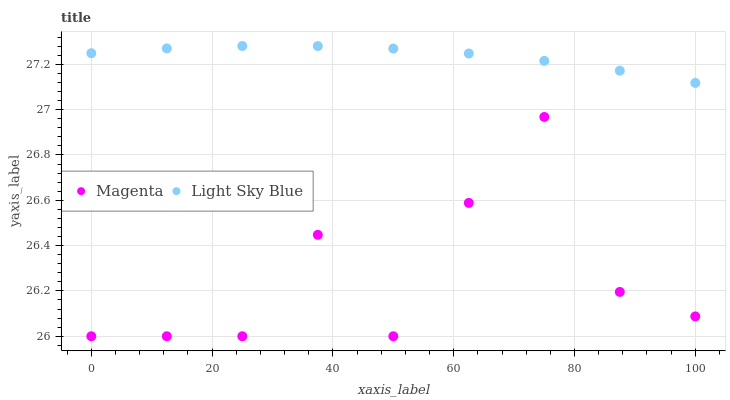Does Magenta have the minimum area under the curve?
Answer yes or no. Yes. Does Light Sky Blue have the maximum area under the curve?
Answer yes or no. Yes. Does Light Sky Blue have the minimum area under the curve?
Answer yes or no. No. Is Light Sky Blue the smoothest?
Answer yes or no. Yes. Is Magenta the roughest?
Answer yes or no. Yes. Is Light Sky Blue the roughest?
Answer yes or no. No. Does Magenta have the lowest value?
Answer yes or no. Yes. Does Light Sky Blue have the lowest value?
Answer yes or no. No. Does Light Sky Blue have the highest value?
Answer yes or no. Yes. Is Magenta less than Light Sky Blue?
Answer yes or no. Yes. Is Light Sky Blue greater than Magenta?
Answer yes or no. Yes. Does Magenta intersect Light Sky Blue?
Answer yes or no. No. 